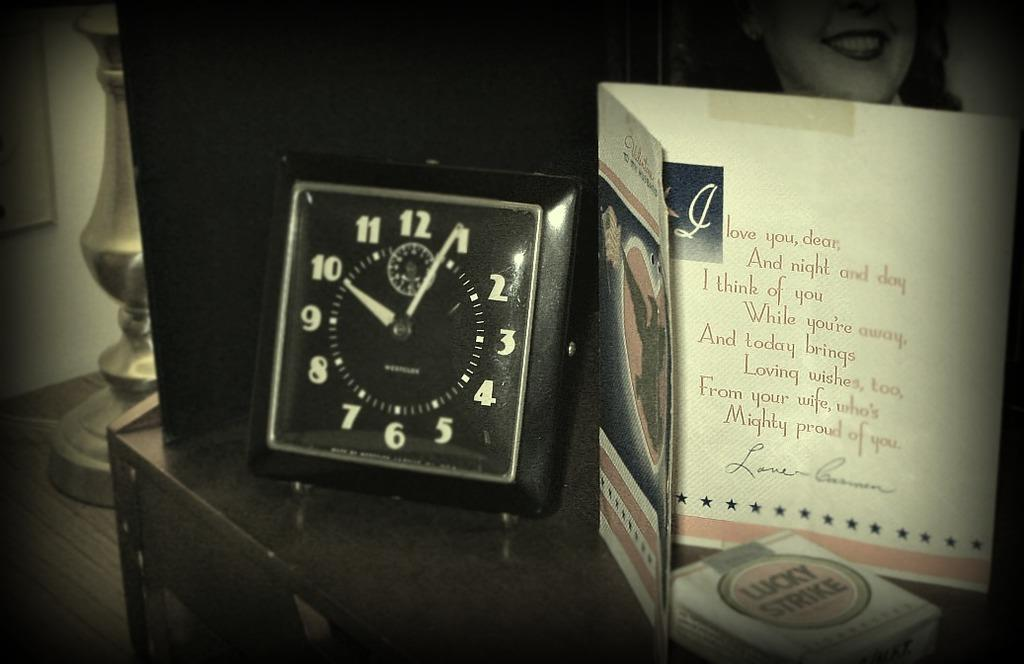<image>
Present a compact description of the photo's key features. the numbers 12 to 1 are on a black and white clock 